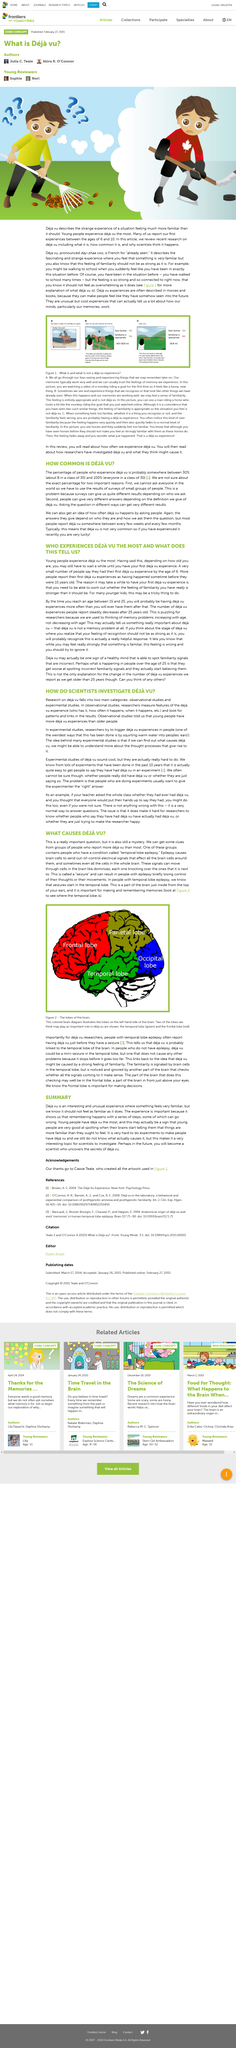Indicate a few pertinent items in this graphic. It is difficult to find an accurate number because only a limited number of people can be asked, and small groups of people often give different answers depending on who is asked and the definition provided. Young people are most likely to experience deja vu. The occipital lobe is located at the back of the left hand side of the brain. Deja vu, the phenomenon of feeling that one has experienced a situation before, is believed to be a common occurrence, but the exact percentage of people who experience it is unknown. It is believed that between 30% and 100% of people have experienced Deja Vu. 